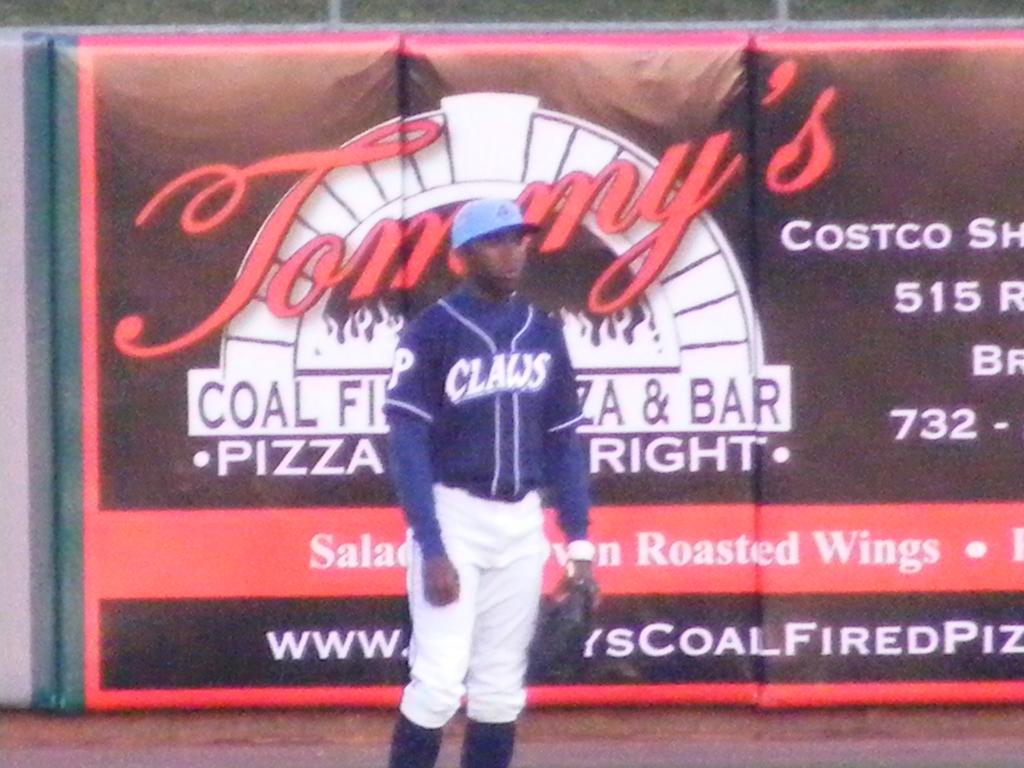Provide a one-sentence caption for the provided image. A baseball player wear a Claws uniform stands in front of a Tommy's pizza advertisement. 